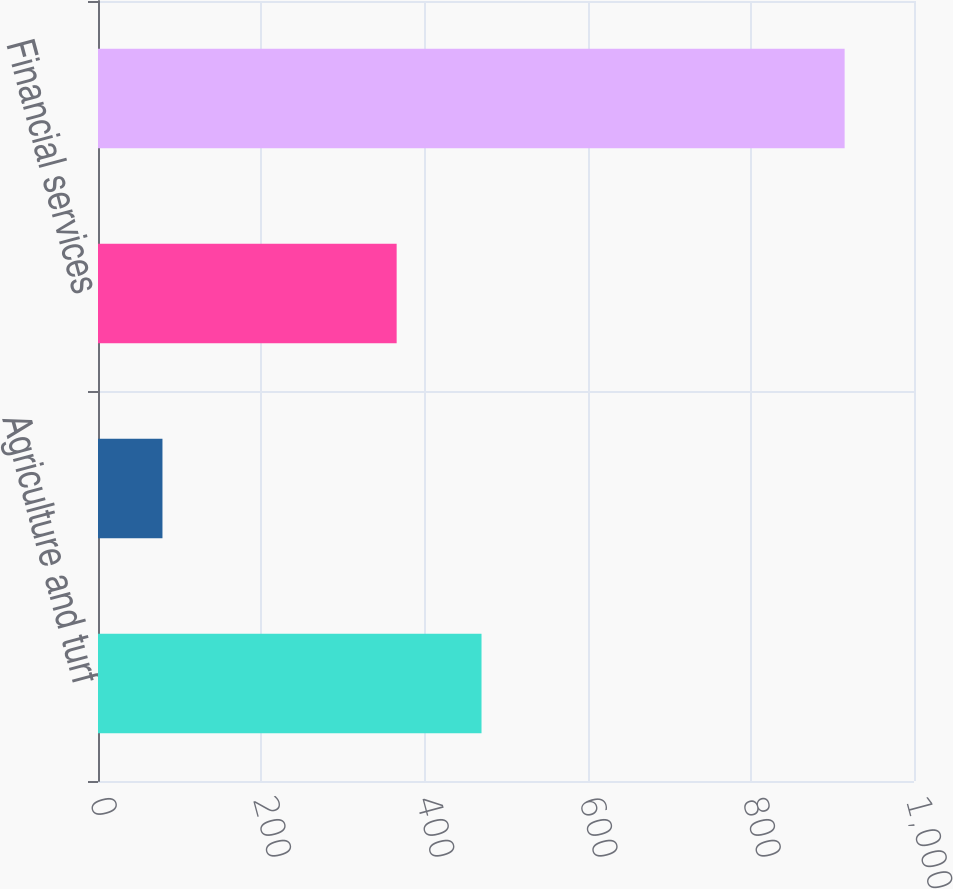Convert chart to OTSL. <chart><loc_0><loc_0><loc_500><loc_500><bar_chart><fcel>Agriculture and turf<fcel>Construction and forestry<fcel>Financial services<fcel>Total<nl><fcel>470<fcel>79<fcel>366<fcel>915<nl></chart> 